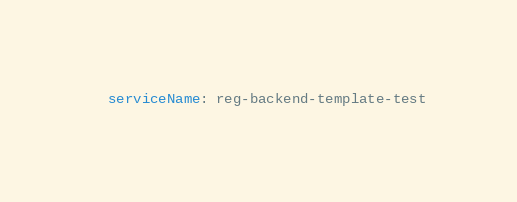Convert code to text. <code><loc_0><loc_0><loc_500><loc_500><_YAML_>  serviceName: reg-backend-template-test
</code> 